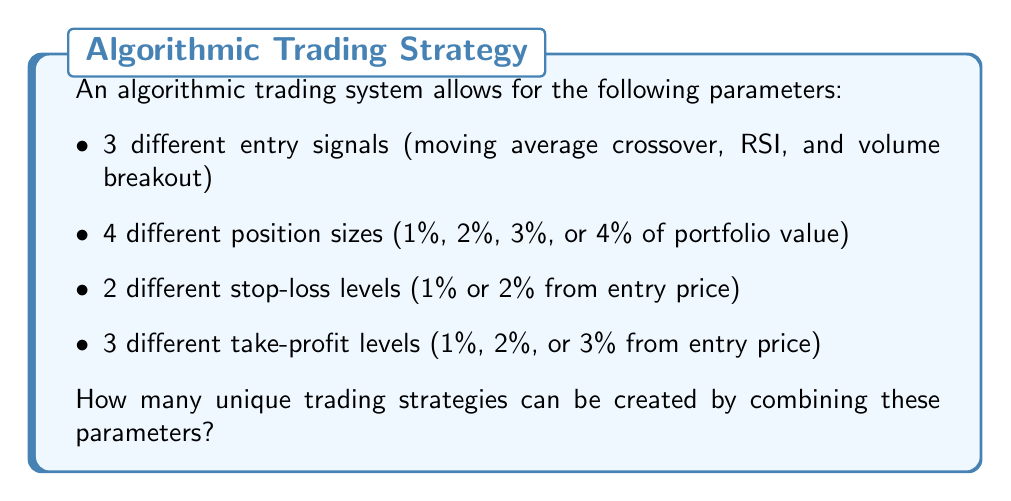Can you solve this math problem? To solve this problem, we'll use the multiplication principle of counting. This principle states that if we have multiple independent choices, the total number of possible outcomes is the product of the number of choices for each parameter.

Let's break it down step-by-step:

1. Entry signals: There are 3 choices
2. Position sizes: There are 4 choices
3. Stop-loss levels: There are 2 choices
4. Take-profit levels: There are 3 choices

Now, we multiply these numbers together:

$$ \text{Total strategies} = 3 \times 4 \times 2 \times 3 $$

$$ = 3 \times 4 \times 6 $$

$$ = 12 \times 6 $$

$$ = 72 $$

Therefore, there are 72 unique trading strategies that can be created by combining these parameters.
Answer: 72 